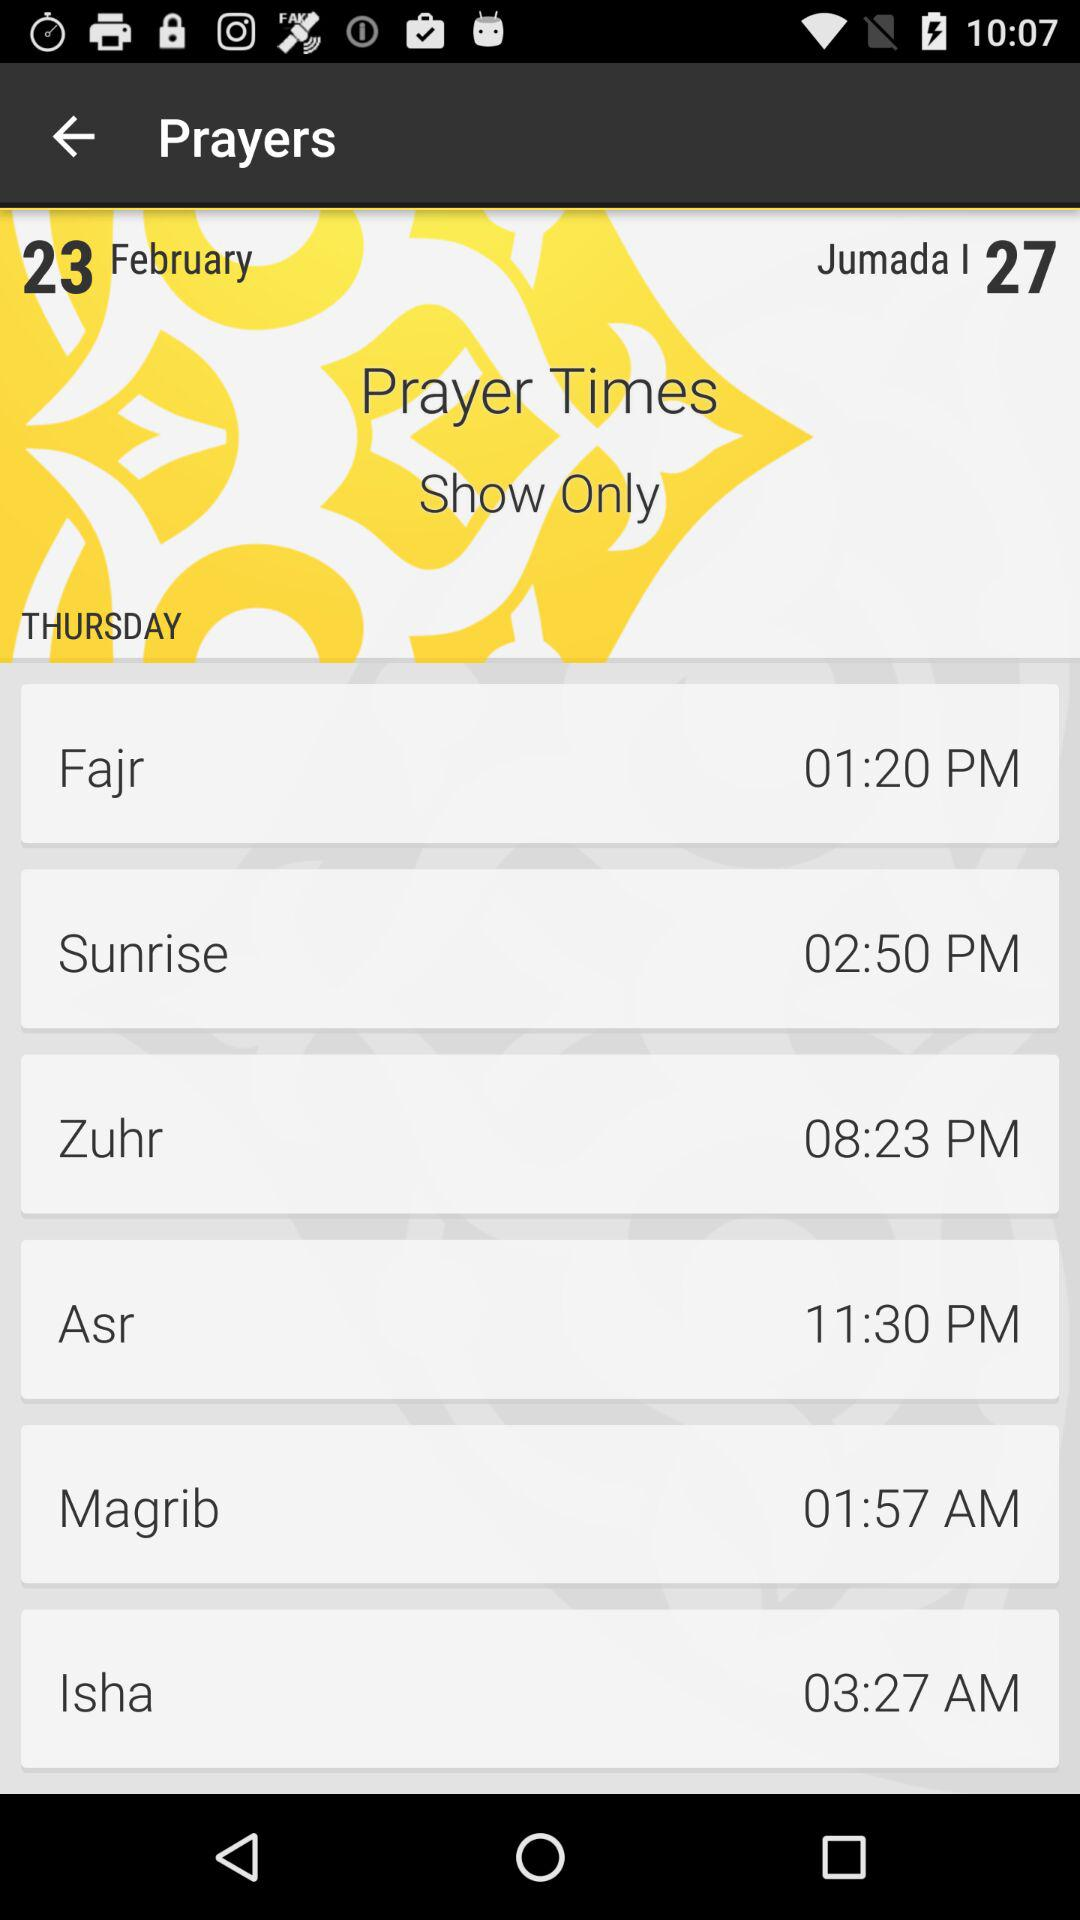What is the prayer time of "Isha"? The prayer time is 3:27 a.m. 